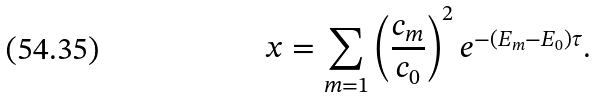Convert formula to latex. <formula><loc_0><loc_0><loc_500><loc_500>x = \sum _ { m = 1 } \left ( \frac { c _ { m } } { c _ { 0 } } \right ) ^ { 2 } e ^ { - ( E _ { m } - E _ { 0 } ) \tau } .</formula> 